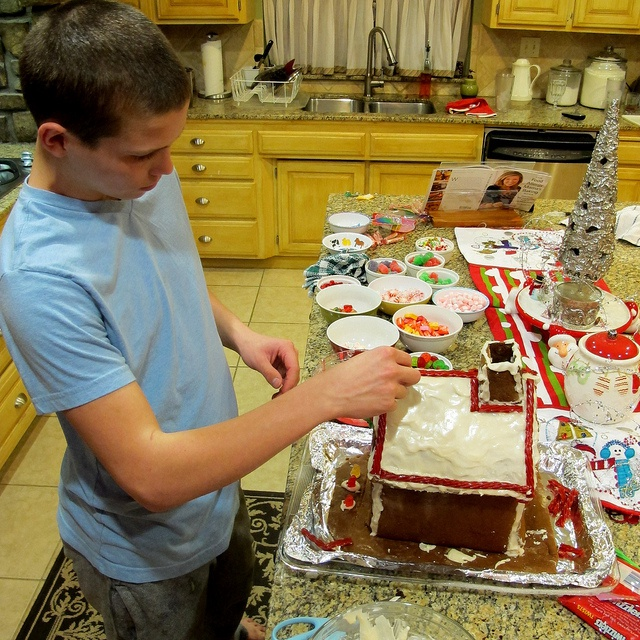Describe the objects in this image and their specific colors. I can see dining table in darkgreen, beige, tan, and maroon tones, people in darkgreen, black, darkgray, gray, and tan tones, cake in darkgreen, beige, and maroon tones, oven in darkgreen, black, olive, and tan tones, and book in darkgreen, tan, brown, and maroon tones in this image. 